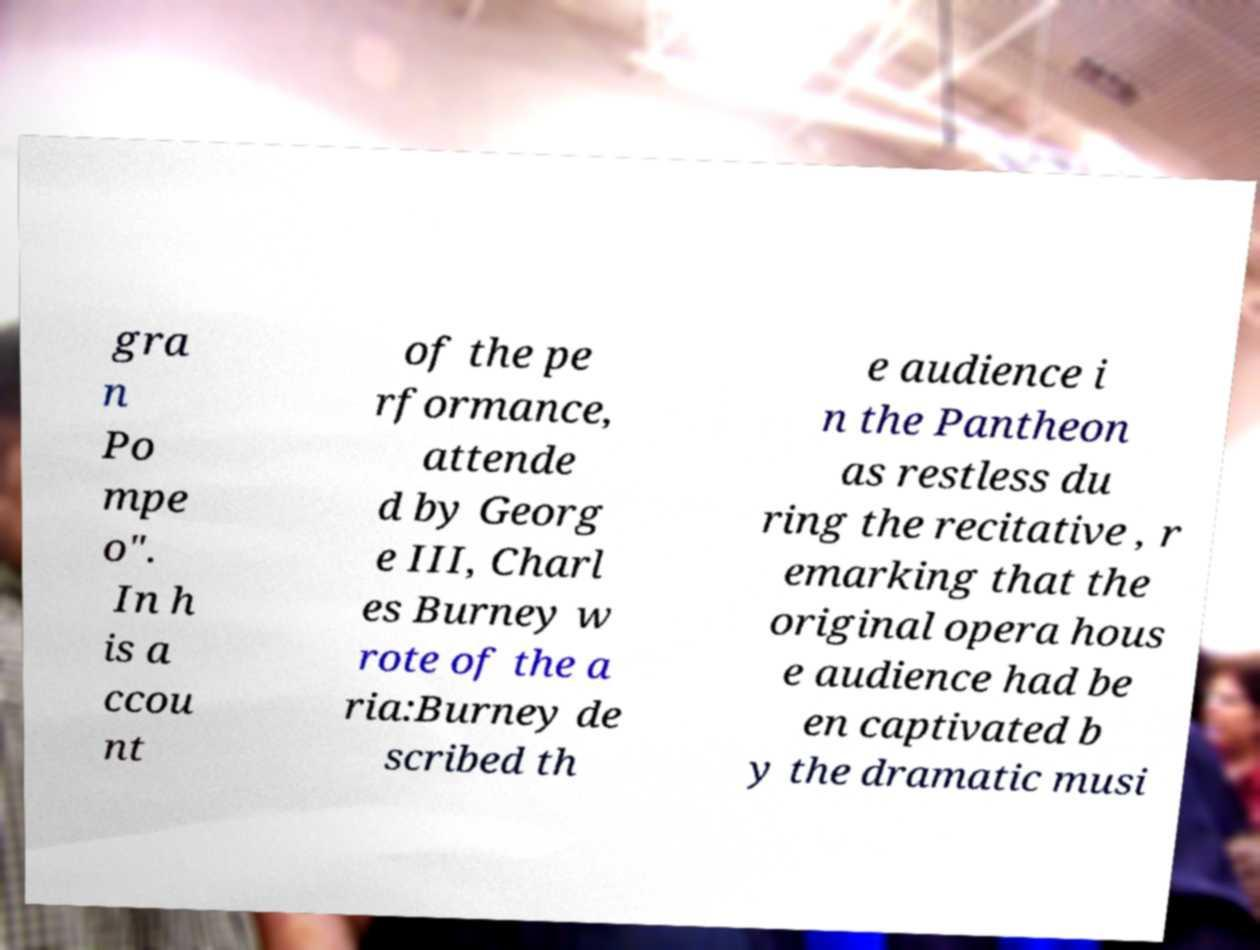Please identify and transcribe the text found in this image. gra n Po mpe o". In h is a ccou nt of the pe rformance, attende d by Georg e III, Charl es Burney w rote of the a ria:Burney de scribed th e audience i n the Pantheon as restless du ring the recitative , r emarking that the original opera hous e audience had be en captivated b y the dramatic musi 